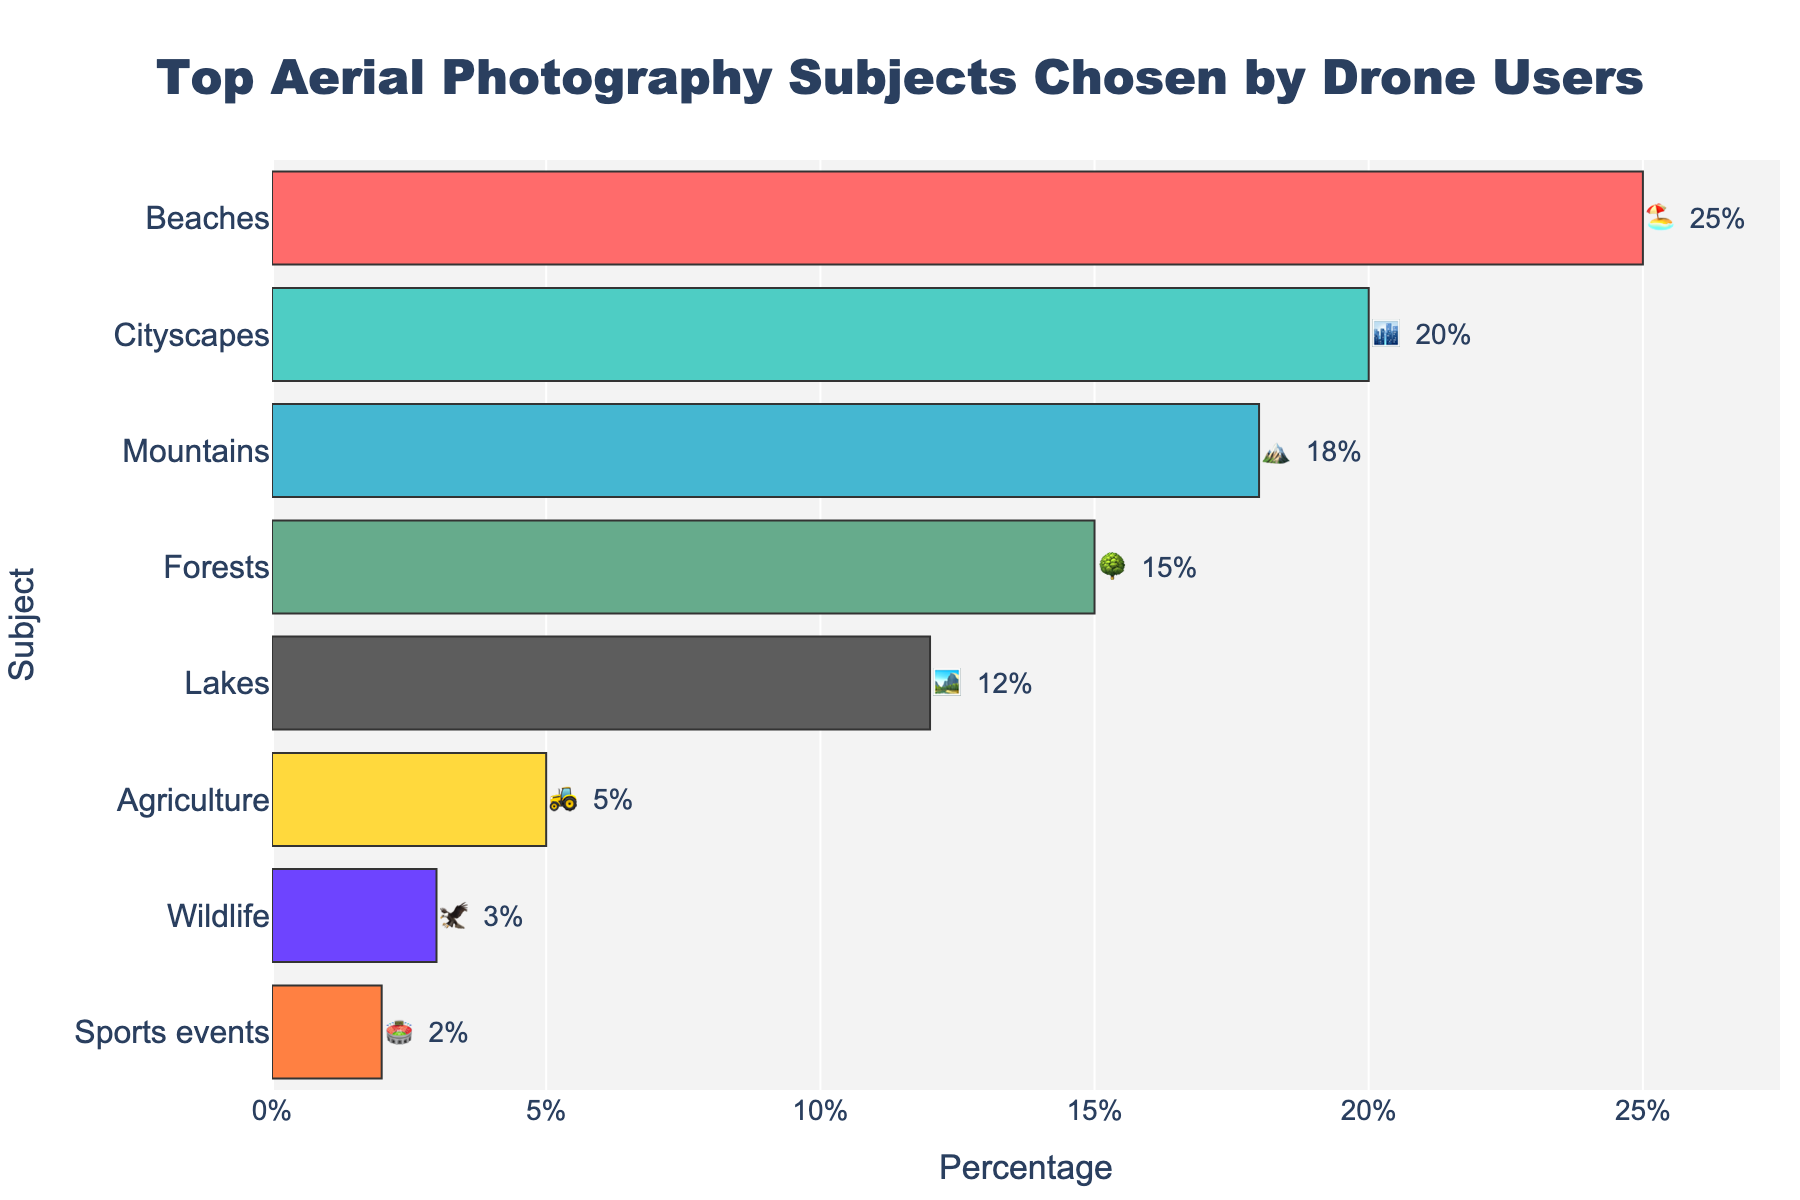What is the subject with the highest percentage of drone users photographing it? The subject with the highest percentage can be found by looking at the bar with the greatest length. The bar labeled "Beaches" is the longest, representing 25%.
Answer: Beaches Which subject has the lowest percentage of drone users photographing it? The smallest bar corresponds to the lowest percentage. The bar for "Sports events" is the shortest with a percentage of 2%.
Answer: Sports events What is the total percentage of users who photograph natural subjects like beaches, mountains, forests, and lakes? Add the percentages for "Beaches" (25%), "Mountains" (18%), "Forests" (15%), and "Lakes" (12%). 25 + 18 + 15 + 12 = 70%.
Answer: 70% Which subjects have more than 15% of drone users photographing them? Look for bars with percentages greater than 15%. These are "Beaches" (25%), "Cityscapes" (20%), and "Mountains" (18%).
Answer: Beaches, Cityscapes, Mountains How much higher is the percentage of users photographing beaches than those photographing lakes? Subtract the percentage for "Lakes" (12%) from the percentage for "Beaches" (25%). 25 - 12 = 13%.
Answer: 13% Which subject has a percentage exactly halfway between the percentages for beaches and forests? Calculate the average of "Beaches" (25%) and "Forests" (15%). (25 + 15) / 2 = 20%. The subject with 20% is "Cityscapes".
Answer: Cityscapes What is the combined percentage of users photographing forests and wildlife? Add the percentages for "Forests" (15%) and "Wildlife" (3%). 15 + 3 = 18%.
Answer: 18% What emoji is used to represent lakes? Look for the emoji associated with the "Lakes" category in the chart.
Answer: 🏞️ Which category has an emoji of a tractor? The emoji 🚜 is associated with the "Agriculture" category in the chart.
Answer: Agriculture Which subjects collectively make up less than 10% of drone users’ favorite photography subjects? Identify subjects with percentages less than 10%. These are "Agriculture" (5%), "Wildlife" (3%), and "Sports events" (2%).
Answer: Agriculture, Wildlife, Sports events 